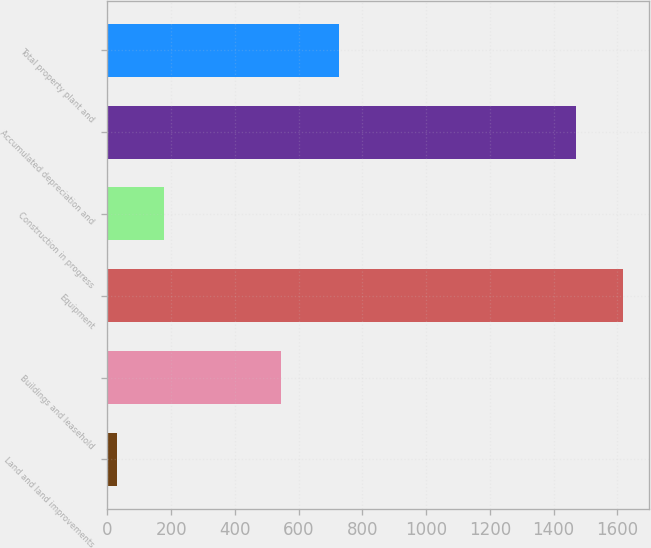<chart> <loc_0><loc_0><loc_500><loc_500><bar_chart><fcel>Land and land improvements<fcel>Buildings and leasehold<fcel>Equipment<fcel>Construction in progress<fcel>Accumulated depreciation and<fcel>Total property plant and<nl><fcel>31<fcel>544<fcel>1617.6<fcel>178.6<fcel>1470<fcel>726<nl></chart> 